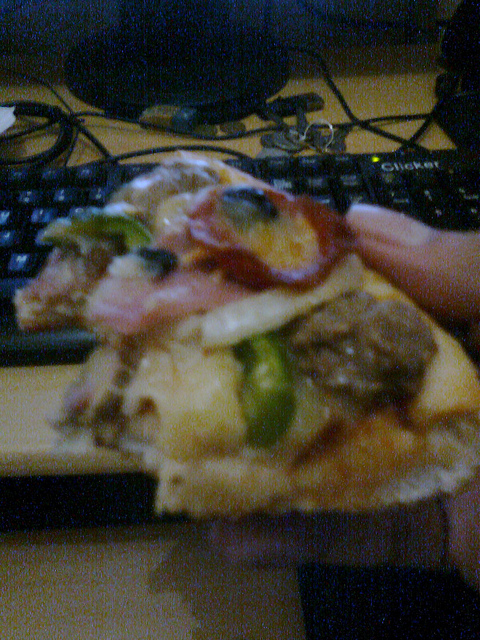<image>What color bowls are pictured? There are no color bowls pictured in this image. What color bowls are pictured? It is unanswerable what color bowls are pictured. There are no colored bowls in the image. 